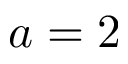Convert formula to latex. <formula><loc_0><loc_0><loc_500><loc_500>a = 2</formula> 